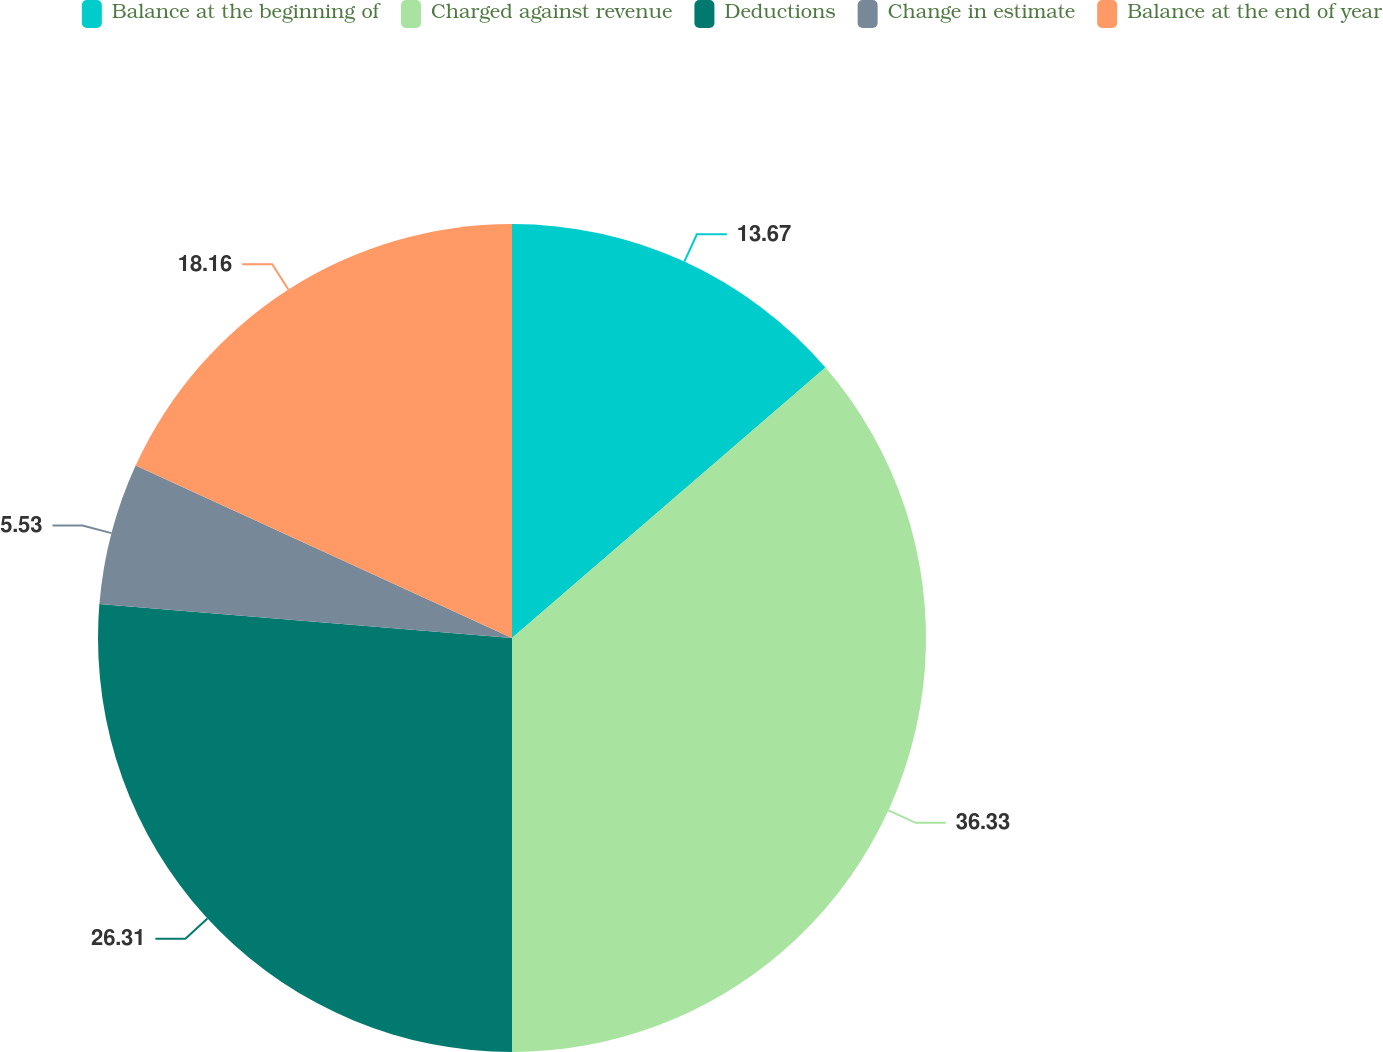Convert chart. <chart><loc_0><loc_0><loc_500><loc_500><pie_chart><fcel>Balance at the beginning of<fcel>Charged against revenue<fcel>Deductions<fcel>Change in estimate<fcel>Balance at the end of year<nl><fcel>13.67%<fcel>36.33%<fcel>26.31%<fcel>5.53%<fcel>18.16%<nl></chart> 